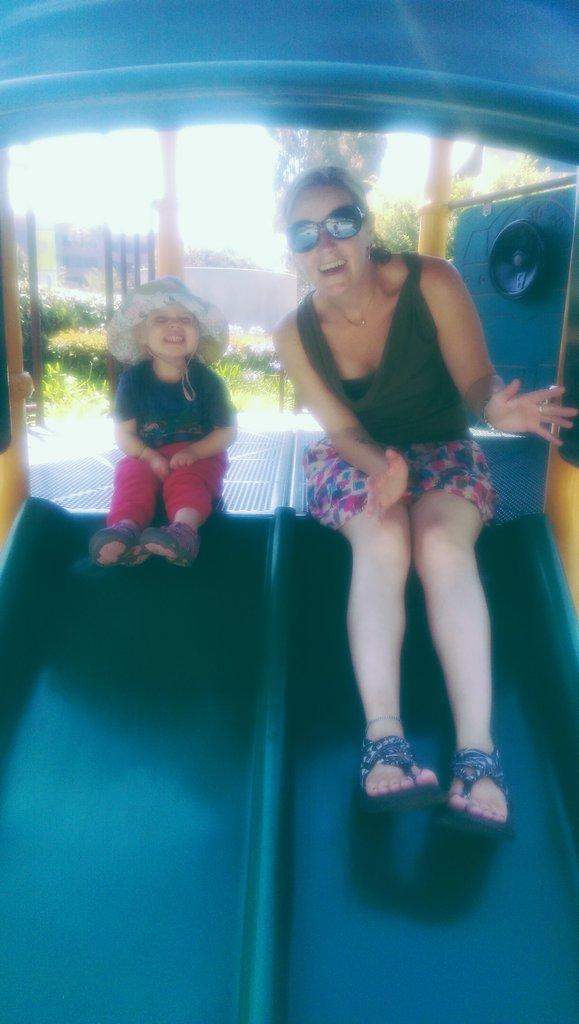Please provide a concise description of this image. In this picture we can observe a woman wearing spectacles and green color dress, sitting on the sliding board. Beside the woman there is a child sitting on the sliding board wearing a hat on her head. In the background there are trees, building and a sky. 